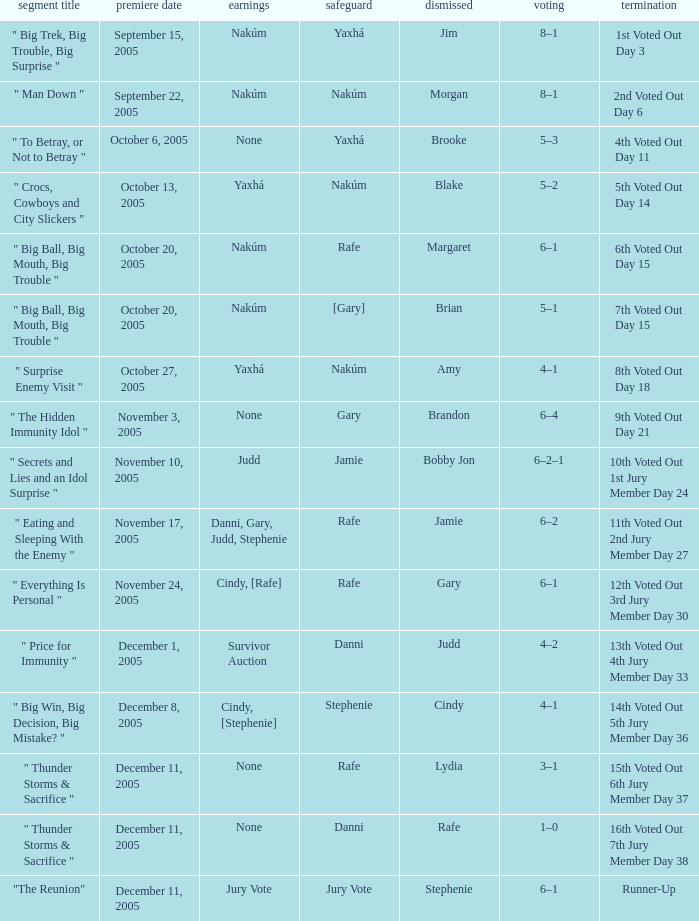How many rewards are there for air date October 6, 2005? None. 